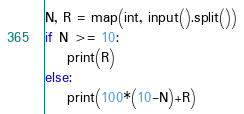<code> <loc_0><loc_0><loc_500><loc_500><_Python_>N, R = map(int, input().split())
if N >= 10:
    print(R)
else:
    print(100*(10-N)+R)</code> 